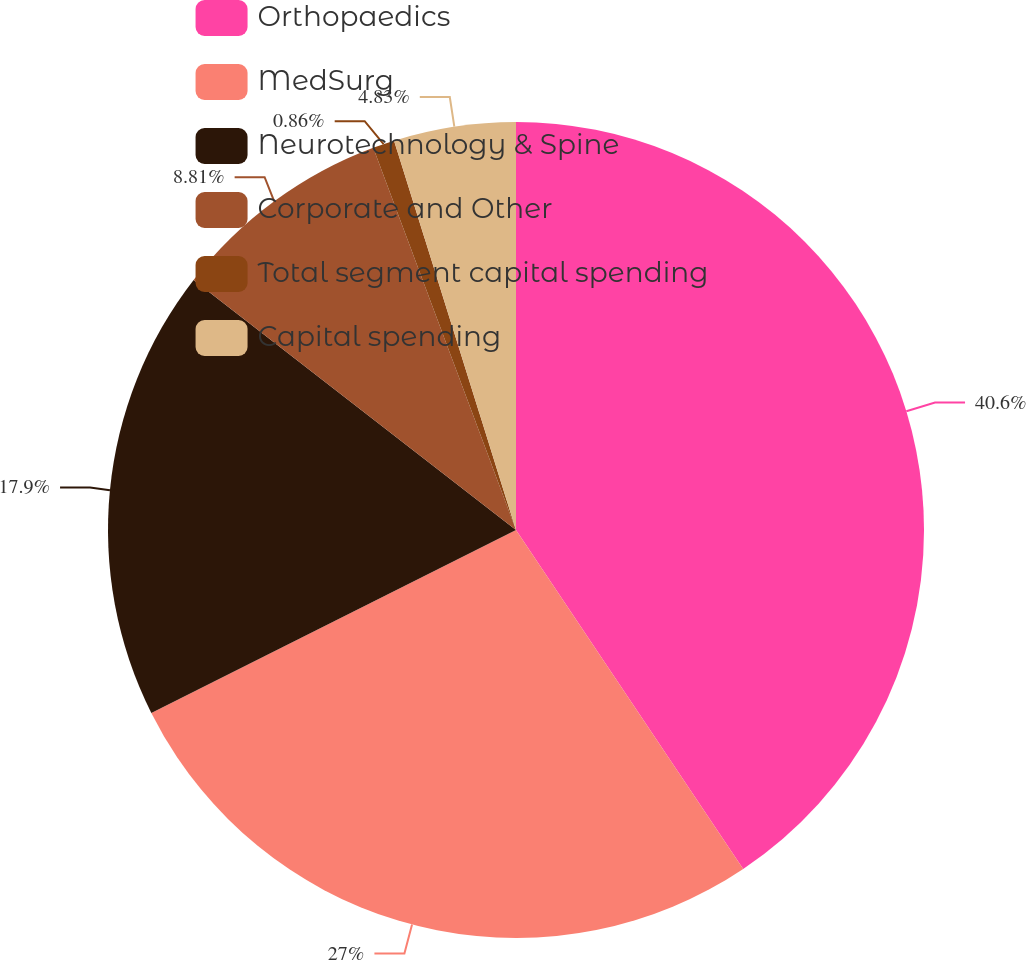Convert chart. <chart><loc_0><loc_0><loc_500><loc_500><pie_chart><fcel>Orthopaedics<fcel>MedSurg<fcel>Neurotechnology & Spine<fcel>Corporate and Other<fcel>Total segment capital spending<fcel>Capital spending<nl><fcel>40.6%<fcel>27.0%<fcel>17.9%<fcel>8.81%<fcel>0.86%<fcel>4.83%<nl></chart> 